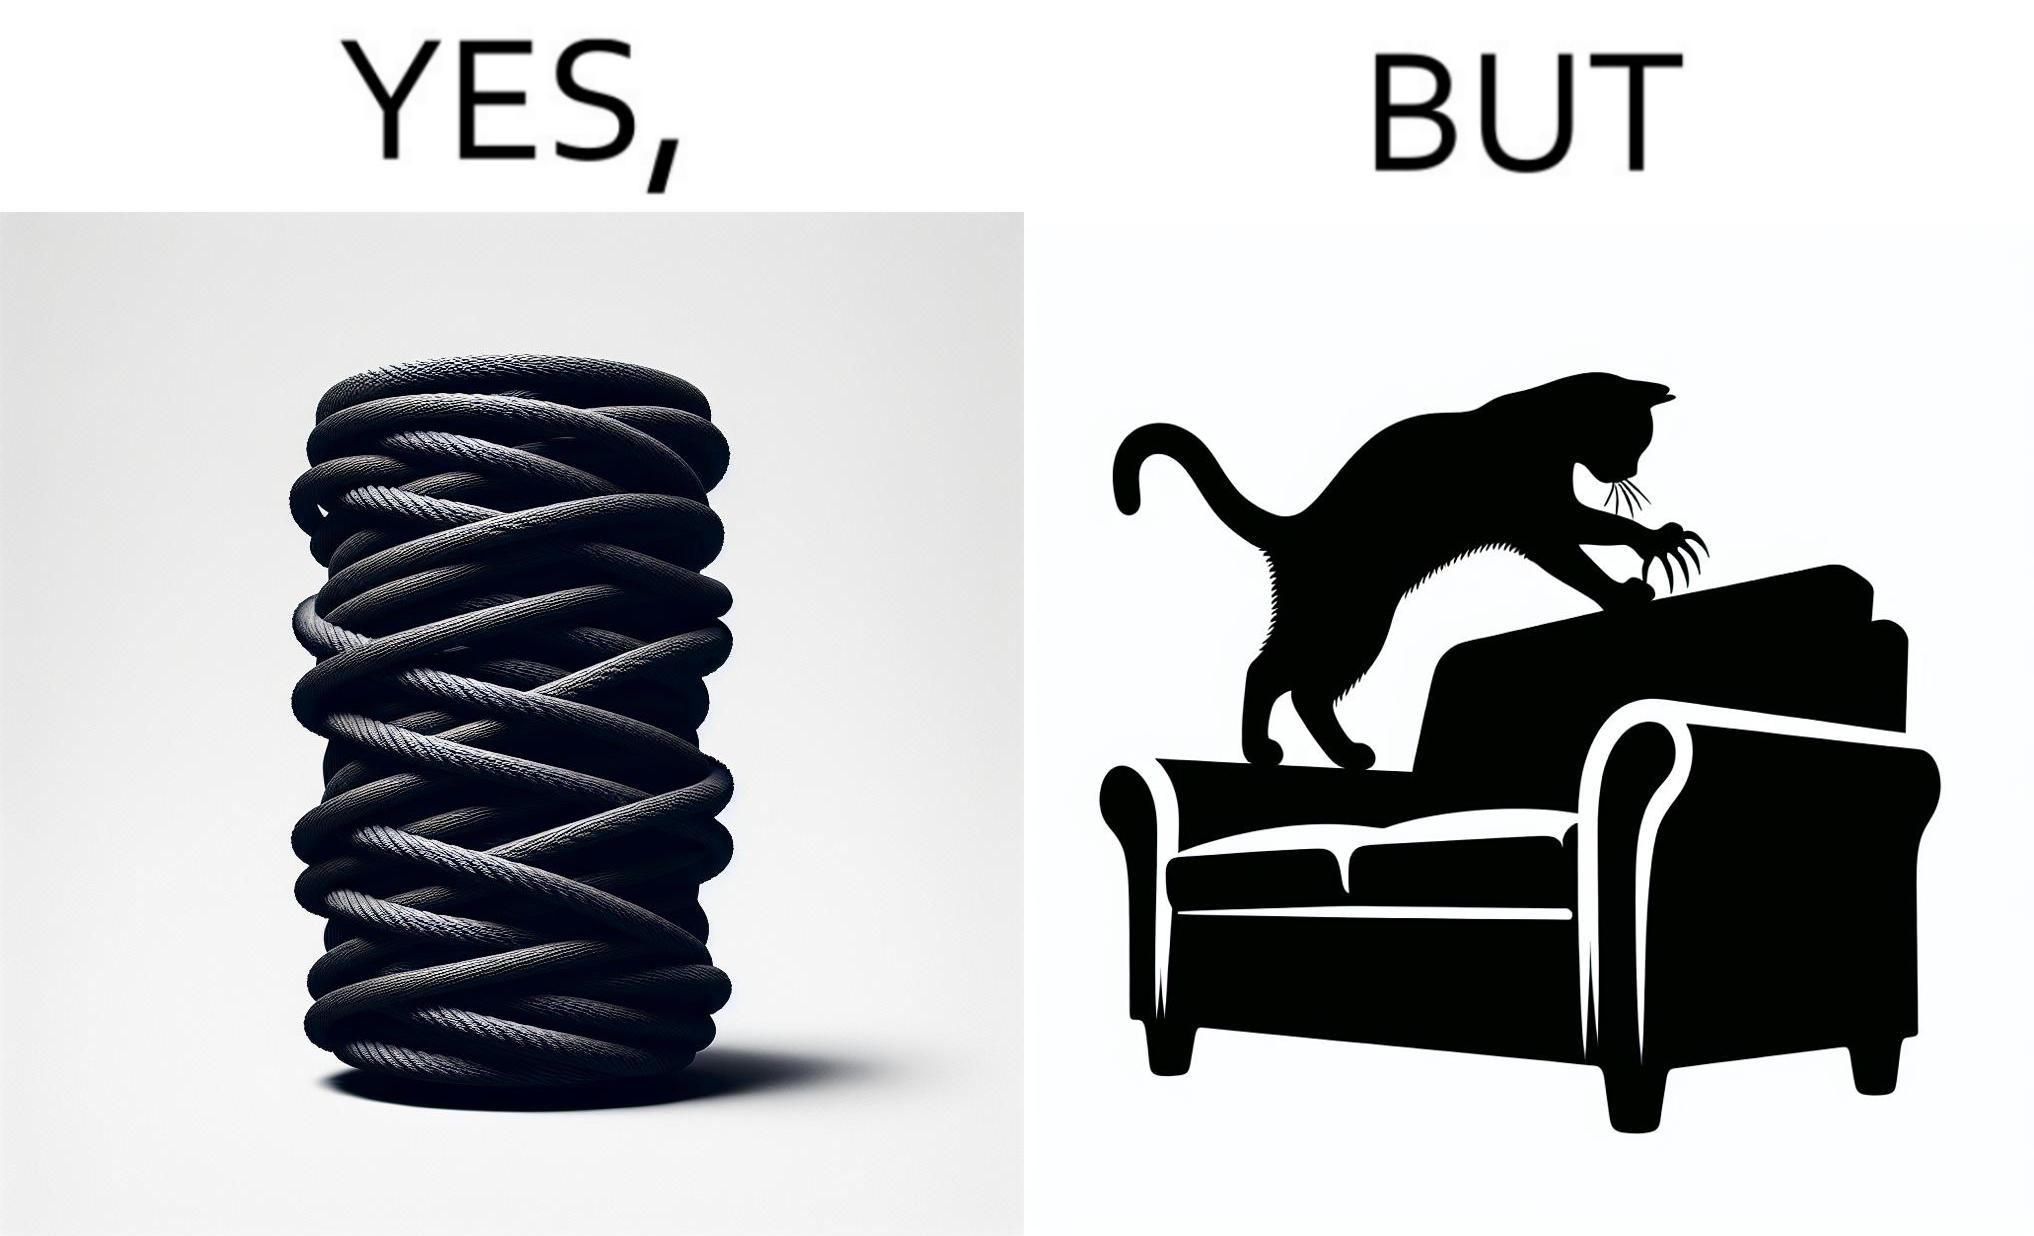Describe the content of this image. The image is ironic, because in the first image a toy, purposed for the cat to play with is shown but in the second image the cat is comfortably enjoying  to play on the sides of sofa 